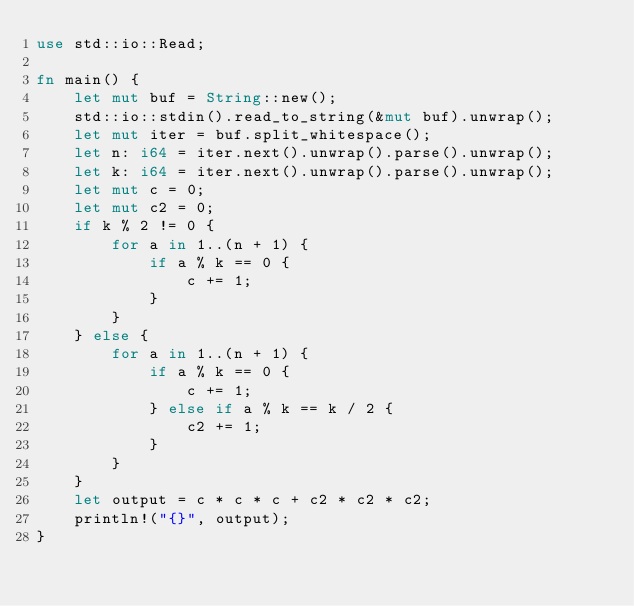<code> <loc_0><loc_0><loc_500><loc_500><_Rust_>use std::io::Read;

fn main() {
    let mut buf = String::new();
    std::io::stdin().read_to_string(&mut buf).unwrap();
    let mut iter = buf.split_whitespace();
    let n: i64 = iter.next().unwrap().parse().unwrap();
    let k: i64 = iter.next().unwrap().parse().unwrap();
    let mut c = 0;
    let mut c2 = 0;
    if k % 2 != 0 {
        for a in 1..(n + 1) {
            if a % k == 0 {
                c += 1;
            }
        }
    } else {
        for a in 1..(n + 1) {
            if a % k == 0 {
                c += 1;
            } else if a % k == k / 2 {
                c2 += 1;
            }
        }
    }
    let output = c * c * c + c2 * c2 * c2;
    println!("{}", output);
}
</code> 